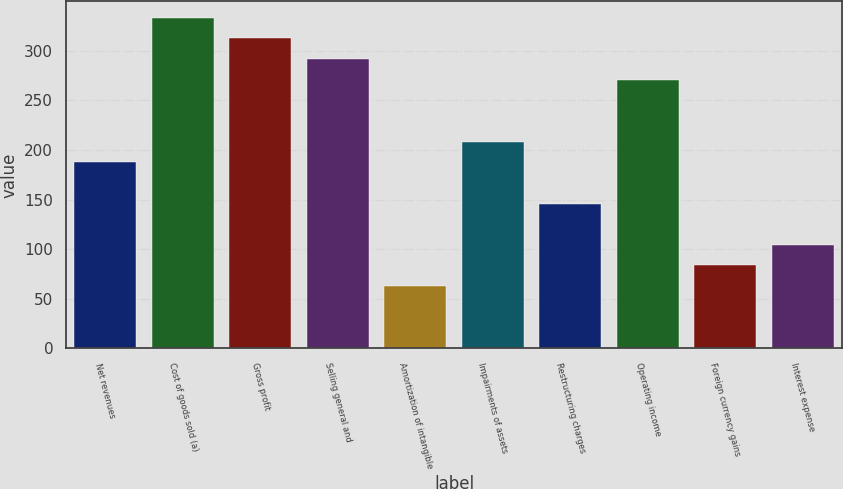Convert chart to OTSL. <chart><loc_0><loc_0><loc_500><loc_500><bar_chart><fcel>Net revenues<fcel>Cost of goods sold (a)<fcel>Gross profit<fcel>Selling general and<fcel>Amortization of intangible<fcel>Impairments of assets<fcel>Restructuring charges<fcel>Operating income<fcel>Foreign currency gains<fcel>Interest expense<nl><fcel>187.62<fcel>333.08<fcel>312.3<fcel>291.52<fcel>62.94<fcel>208.4<fcel>146.06<fcel>270.74<fcel>83.72<fcel>104.5<nl></chart> 